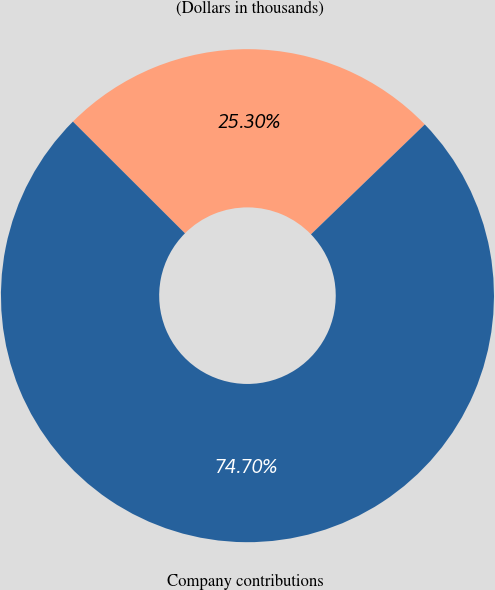Convert chart to OTSL. <chart><loc_0><loc_0><loc_500><loc_500><pie_chart><fcel>(Dollars in thousands)<fcel>Company contributions<nl><fcel>25.3%<fcel>74.7%<nl></chart> 